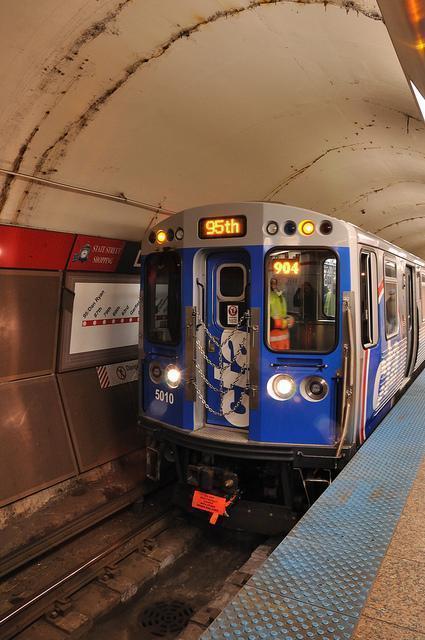In what US city is this subway station located in?
Answer the question by selecting the correct answer among the 4 following choices.
Options: Los angeles, chicago, new york, seattle. Chicago. 